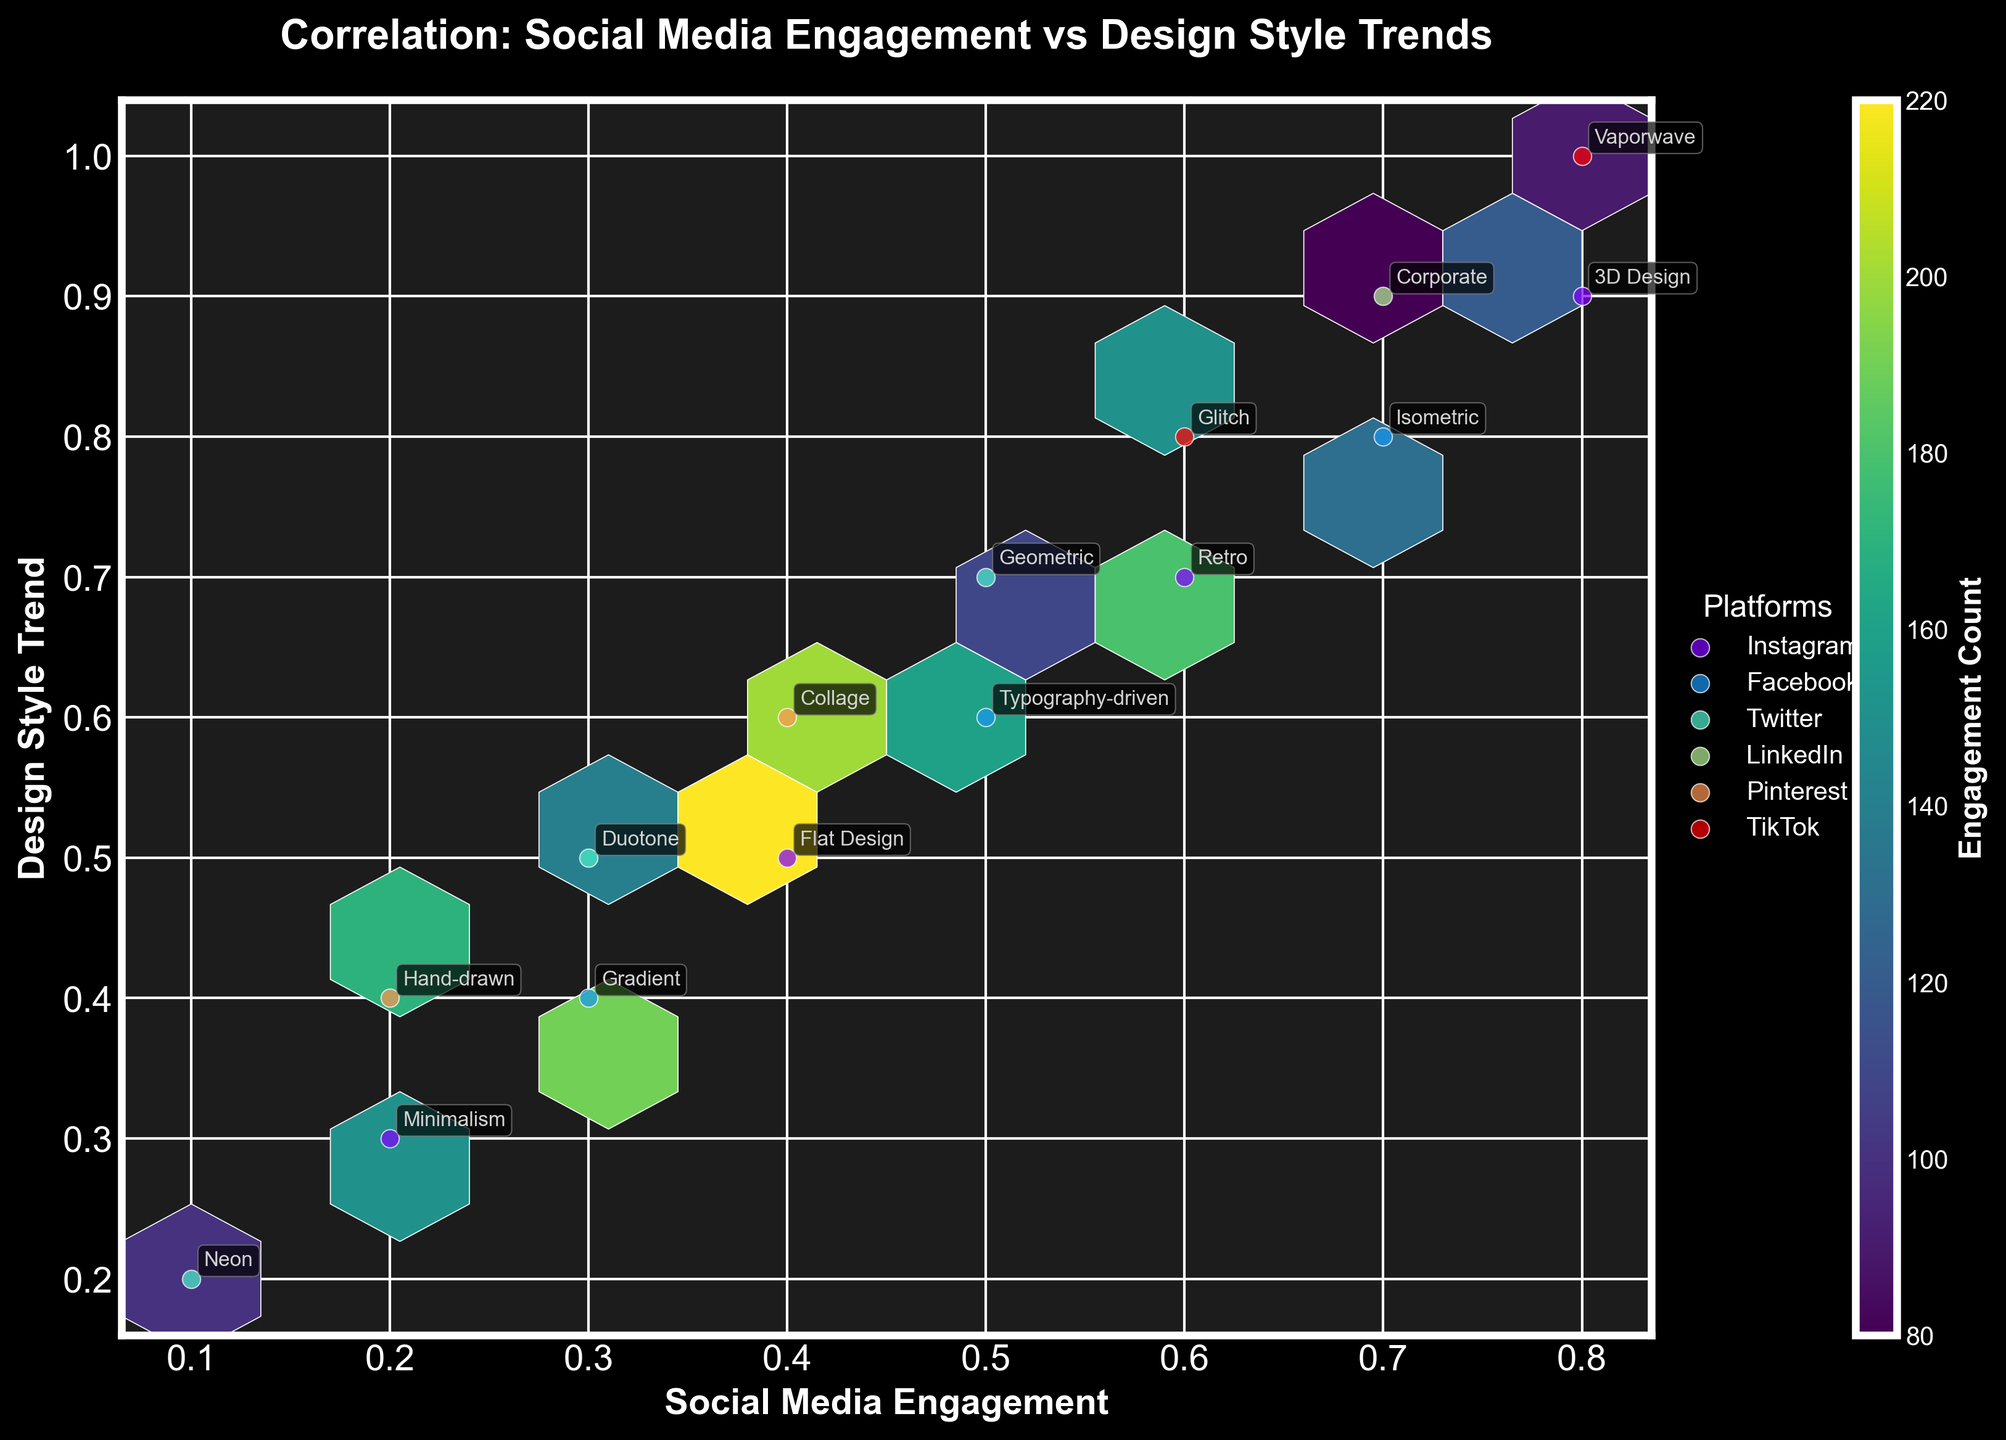What is the title of the Hexbin Plot? The title appears at the top of the plot, clearly stating the main idea being visualized. In this case, it is "Correlation: Social Media Engagement vs Design Style Trends."
Answer: Correlation: Social Media Engagement vs Design Style Trends What color scheme is used in the Hexbin Plot? The color scheme or colormap used in the plot affects the color range used to fill the hexagons indicating engagement counts. The figure uses the 'viridis' colormap which ranges from dark purple to yellow.
Answer: Viridis Which design style has the highest engagement count on Instagram? By looking at the plot and identifying the hexagons with the highest color density (brightest yellow) specifically for Instagram, we find that the highest engagement count is for the "Flat Design" style.
Answer: Flat Design How many age groups are represented in the data? The distinct age groups can be determined from the annotations next to the data points. On inspection, we can see 18-24, 25-34, 35-44, and 45-54 are included in the plot.
Answer: Four What age group shows the most engagement with the "Hand-drawn" design style on Pinterest? By locating the annotation for "Hand-drawn" on Pinterest and checking the corresponding age group, we find it is the 25-34 age group.
Answer: 25-34 Compare the engagement of "Neon" and "Glitch" design styles on their respective platforms. Which one is higher? By locating the annotations for "Neon" on Twitter and "Glitch" on TikTok and observing their corresponding color densities, the engagement count for "Glitch" on TikTok appears higher due to a brighter hexbin color.
Answer: Glitch Which social media platform has the most diverse range of design styles? By observing the number of different design style annotations within each platform's color points, Instagram shows a higher variety of styles (Minimalism, Flat Design, Retro, and 3D Design).
Answer: Instagram What is the overall trend in engagement with respect to increasing design complexity across platforms? By examining the distribution of engagement counts and design styles across the entire plot, we see that more complex designs (e.g., 3D, Isometric) generally show lower engagement counts compared to simpler designs (e.g., Flat Design, Minimalism).
Answer: Lower engagement for complex designs Which platform shows the highest concentration of engagement for the age group 35-44? By identifying the plotted data points associated with the 35-44 age group across all platforms and looking for the highest engagement counts (brightest hexbin colors), Pinterest and Instagram both show high engagements. However, Instagram's 35-44 age group's highest engagement is more pronounced.
Answer: Instagram 